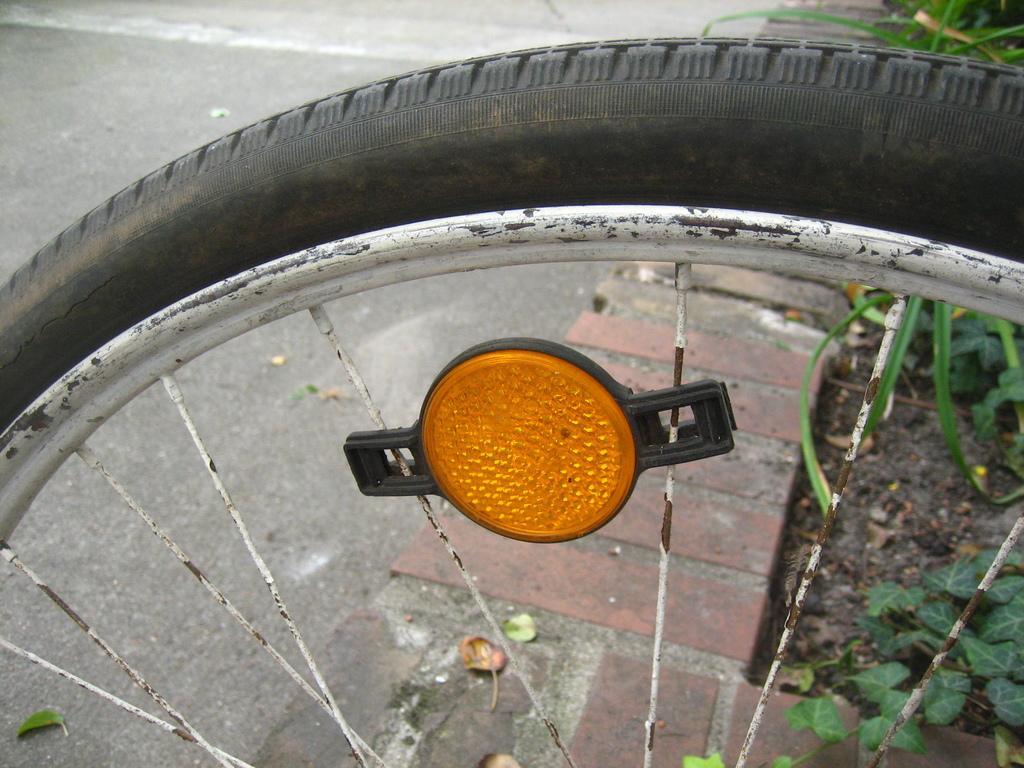Describe this image in one or two sentences. In this image we can see a tire with rims. Also there is a light. In the back there are plants and a brick wall. 